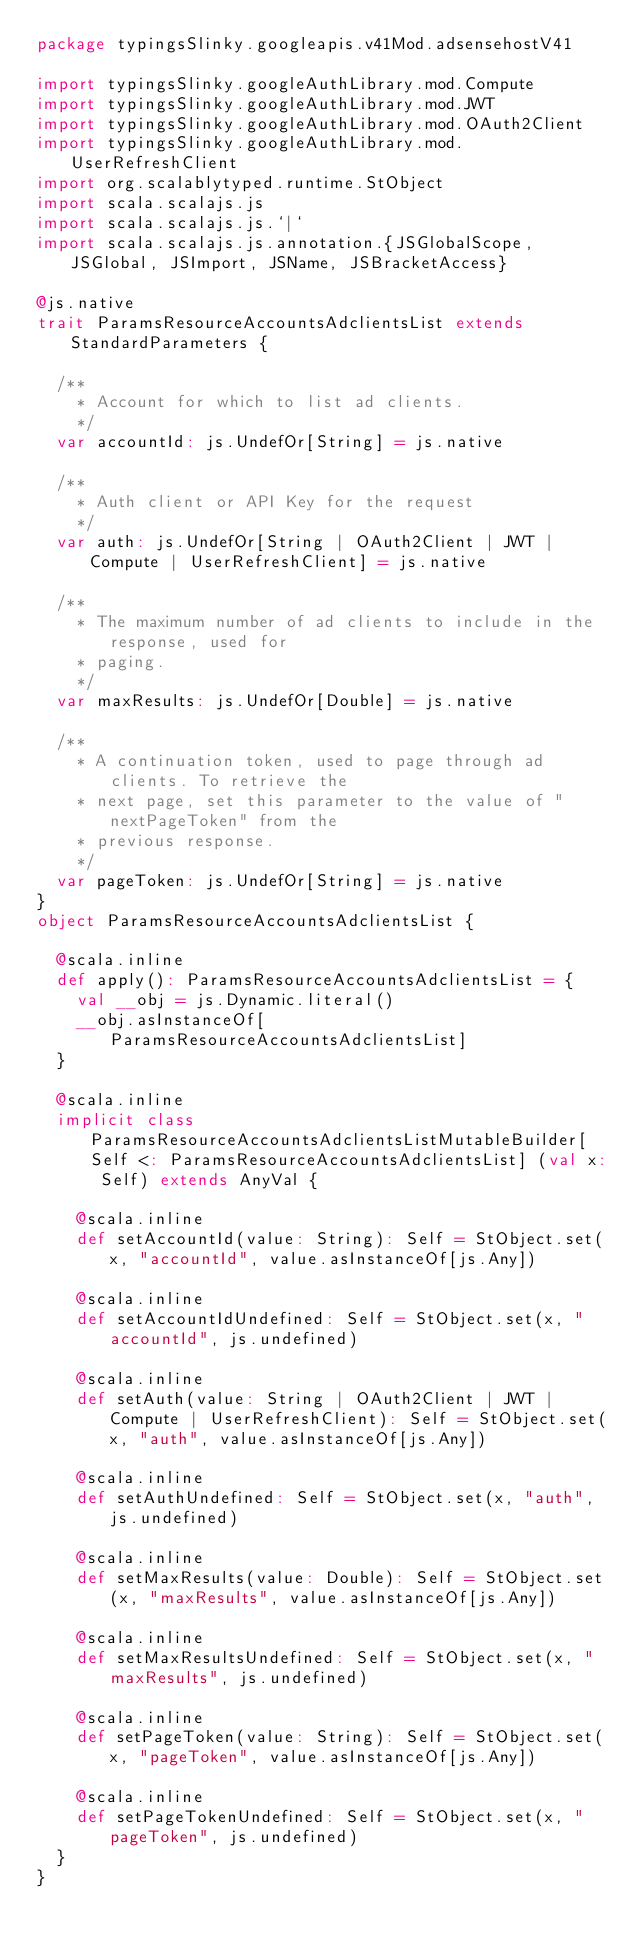<code> <loc_0><loc_0><loc_500><loc_500><_Scala_>package typingsSlinky.googleapis.v41Mod.adsensehostV41

import typingsSlinky.googleAuthLibrary.mod.Compute
import typingsSlinky.googleAuthLibrary.mod.JWT
import typingsSlinky.googleAuthLibrary.mod.OAuth2Client
import typingsSlinky.googleAuthLibrary.mod.UserRefreshClient
import org.scalablytyped.runtime.StObject
import scala.scalajs.js
import scala.scalajs.js.`|`
import scala.scalajs.js.annotation.{JSGlobalScope, JSGlobal, JSImport, JSName, JSBracketAccess}

@js.native
trait ParamsResourceAccountsAdclientsList extends StandardParameters {
  
  /**
    * Account for which to list ad clients.
    */
  var accountId: js.UndefOr[String] = js.native
  
  /**
    * Auth client or API Key for the request
    */
  var auth: js.UndefOr[String | OAuth2Client | JWT | Compute | UserRefreshClient] = js.native
  
  /**
    * The maximum number of ad clients to include in the response, used for
    * paging.
    */
  var maxResults: js.UndefOr[Double] = js.native
  
  /**
    * A continuation token, used to page through ad clients. To retrieve the
    * next page, set this parameter to the value of "nextPageToken" from the
    * previous response.
    */
  var pageToken: js.UndefOr[String] = js.native
}
object ParamsResourceAccountsAdclientsList {
  
  @scala.inline
  def apply(): ParamsResourceAccountsAdclientsList = {
    val __obj = js.Dynamic.literal()
    __obj.asInstanceOf[ParamsResourceAccountsAdclientsList]
  }
  
  @scala.inline
  implicit class ParamsResourceAccountsAdclientsListMutableBuilder[Self <: ParamsResourceAccountsAdclientsList] (val x: Self) extends AnyVal {
    
    @scala.inline
    def setAccountId(value: String): Self = StObject.set(x, "accountId", value.asInstanceOf[js.Any])
    
    @scala.inline
    def setAccountIdUndefined: Self = StObject.set(x, "accountId", js.undefined)
    
    @scala.inline
    def setAuth(value: String | OAuth2Client | JWT | Compute | UserRefreshClient): Self = StObject.set(x, "auth", value.asInstanceOf[js.Any])
    
    @scala.inline
    def setAuthUndefined: Self = StObject.set(x, "auth", js.undefined)
    
    @scala.inline
    def setMaxResults(value: Double): Self = StObject.set(x, "maxResults", value.asInstanceOf[js.Any])
    
    @scala.inline
    def setMaxResultsUndefined: Self = StObject.set(x, "maxResults", js.undefined)
    
    @scala.inline
    def setPageToken(value: String): Self = StObject.set(x, "pageToken", value.asInstanceOf[js.Any])
    
    @scala.inline
    def setPageTokenUndefined: Self = StObject.set(x, "pageToken", js.undefined)
  }
}
</code> 